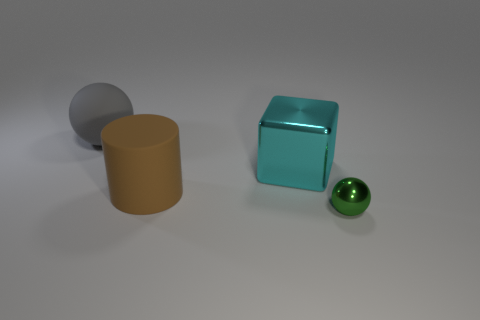Is there a big shiny thing on the left side of the metallic thing to the left of the thing in front of the brown rubber thing?
Offer a terse response. No. Is the material of the sphere behind the big matte cylinder the same as the cube?
Offer a very short reply. No. What is the color of the large thing that is the same shape as the small thing?
Keep it short and to the point. Gray. Is there anything else that is the same shape as the big gray matte object?
Your answer should be very brief. Yes. Are there the same number of large matte objects left of the matte sphere and matte cylinders?
Offer a terse response. No. There is a cyan metal object; are there any metal cubes to the right of it?
Make the answer very short. No. There is a brown thing that is to the right of the sphere that is to the left of the big rubber thing that is in front of the large metallic cube; what is its size?
Keep it short and to the point. Large. Do the large object that is in front of the big shiny thing and the large cyan metallic thing that is right of the gray rubber ball have the same shape?
Give a very brief answer. No. What size is the gray matte object that is the same shape as the tiny green metallic thing?
Make the answer very short. Large. How many cubes are made of the same material as the brown cylinder?
Your answer should be compact. 0. 